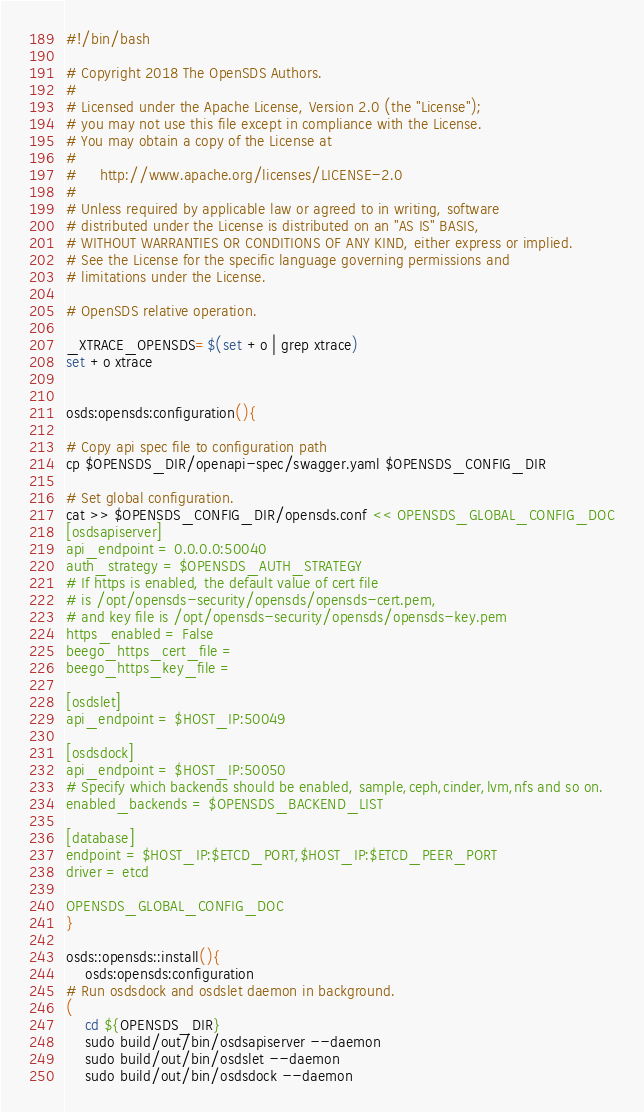<code> <loc_0><loc_0><loc_500><loc_500><_Bash_>#!/bin/bash

# Copyright 2018 The OpenSDS Authors.
#
# Licensed under the Apache License, Version 2.0 (the "License");
# you may not use this file except in compliance with the License.
# You may obtain a copy of the License at
#
#     http://www.apache.org/licenses/LICENSE-2.0
#
# Unless required by applicable law or agreed to in writing, software
# distributed under the License is distributed on an "AS IS" BASIS,
# WITHOUT WARRANTIES OR CONDITIONS OF ANY KIND, either express or implied.
# See the License for the specific language governing permissions and
# limitations under the License.

# OpenSDS relative operation.

_XTRACE_OPENSDS=$(set +o | grep xtrace)
set +o xtrace


osds:opensds:configuration(){

# Copy api spec file to configuration path
cp $OPENSDS_DIR/openapi-spec/swagger.yaml $OPENSDS_CONFIG_DIR

# Set global configuration.
cat >> $OPENSDS_CONFIG_DIR/opensds.conf << OPENSDS_GLOBAL_CONFIG_DOC
[osdsapiserver]
api_endpoint = 0.0.0.0:50040
auth_strategy = $OPENSDS_AUTH_STRATEGY
# If https is enabled, the default value of cert file
# is /opt/opensds-security/opensds/opensds-cert.pem,
# and key file is /opt/opensds-security/opensds/opensds-key.pem
https_enabled = False
beego_https_cert_file =
beego_https_key_file =

[osdslet]
api_endpoint = $HOST_IP:50049

[osdsdock]
api_endpoint = $HOST_IP:50050
# Specify which backends should be enabled, sample,ceph,cinder,lvm,nfs and so on.
enabled_backends = $OPENSDS_BACKEND_LIST

[database]
endpoint = $HOST_IP:$ETCD_PORT,$HOST_IP:$ETCD_PEER_PORT
driver = etcd

OPENSDS_GLOBAL_CONFIG_DOC
}

osds::opensds::install(){
    osds:opensds:configuration
# Run osdsdock and osdslet daemon in background.
(
    cd ${OPENSDS_DIR}
    sudo build/out/bin/osdsapiserver --daemon
    sudo build/out/bin/osdslet --daemon
    sudo build/out/bin/osdsdock --daemon
</code> 